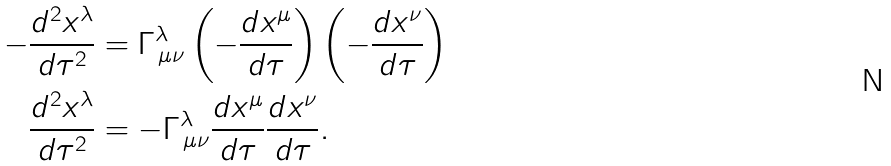<formula> <loc_0><loc_0><loc_500><loc_500>- \frac { d ^ { 2 } x ^ { \lambda } } { d \tau ^ { 2 } } & = \Gamma ^ { \lambda } _ { \, \mu \nu } \left ( - \frac { d x ^ { \mu } } { d \tau } \right ) \left ( - \frac { d x ^ { \nu } } { d \tau } \right ) \\ \frac { d ^ { 2 } x ^ { \lambda } } { d \tau ^ { 2 } } & = - \Gamma ^ { \lambda } _ { \, \mu \nu } \frac { d x ^ { \mu } } { d \tau } \frac { d x ^ { \nu } } { d \tau } .</formula> 